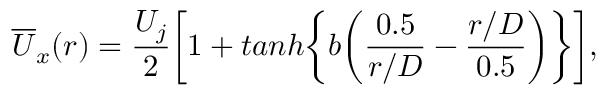<formula> <loc_0><loc_0><loc_500><loc_500>\overline { U } _ { x } ( r ) = \frac { U _ { j } } { 2 } \left [ 1 + t a n h \left \{ b \left ( \frac { 0 . 5 } { r / D } - \frac { r / D } { 0 . 5 } \right ) \right \} \right ] ,</formula> 